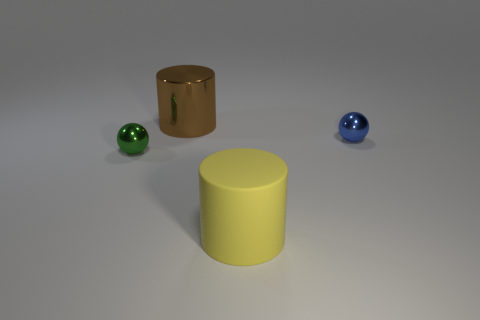Add 3 blue spheres. How many objects exist? 7 Add 1 tiny green things. How many tiny green things are left? 2 Add 2 tiny blue matte cylinders. How many tiny blue matte cylinders exist? 2 Subtract 0 purple cylinders. How many objects are left? 4 Subtract all small blue spheres. Subtract all tiny balls. How many objects are left? 1 